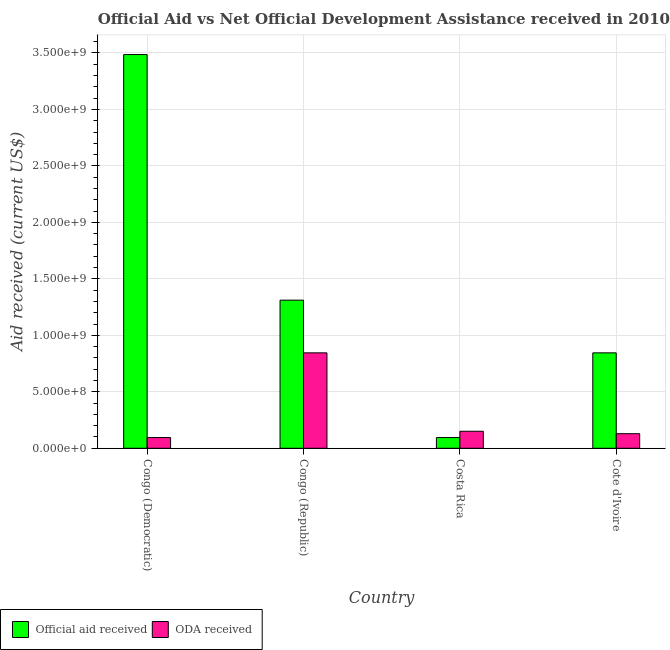How many different coloured bars are there?
Provide a short and direct response. 2. How many groups of bars are there?
Keep it short and to the point. 4. What is the label of the 2nd group of bars from the left?
Your answer should be compact. Congo (Republic). In how many cases, is the number of bars for a given country not equal to the number of legend labels?
Your response must be concise. 0. What is the official aid received in Costa Rica?
Ensure brevity in your answer.  9.50e+07. Across all countries, what is the maximum oda received?
Offer a very short reply. 8.45e+08. Across all countries, what is the minimum official aid received?
Offer a very short reply. 9.50e+07. In which country was the oda received maximum?
Provide a short and direct response. Congo (Republic). What is the total official aid received in the graph?
Give a very brief answer. 5.74e+09. What is the difference between the official aid received in Costa Rica and that in Cote d'Ivoire?
Ensure brevity in your answer.  -7.50e+08. What is the difference between the official aid received in Costa Rica and the oda received in Cote d'Ivoire?
Your response must be concise. -3.41e+07. What is the average oda received per country?
Give a very brief answer. 3.05e+08. What is the difference between the official aid received and oda received in Congo (Democratic)?
Provide a succinct answer. 3.39e+09. What is the ratio of the official aid received in Costa Rica to that in Cote d'Ivoire?
Make the answer very short. 0.11. Is the oda received in Costa Rica less than that in Cote d'Ivoire?
Give a very brief answer. No. What is the difference between the highest and the second highest oda received?
Your answer should be compact. 6.94e+08. What is the difference between the highest and the lowest official aid received?
Ensure brevity in your answer.  3.39e+09. What does the 1st bar from the left in Costa Rica represents?
Your answer should be compact. Official aid received. What does the 1st bar from the right in Cote d'Ivoire represents?
Give a very brief answer. ODA received. How many bars are there?
Your response must be concise. 8. Are all the bars in the graph horizontal?
Your response must be concise. No. How many countries are there in the graph?
Provide a short and direct response. 4. Are the values on the major ticks of Y-axis written in scientific E-notation?
Ensure brevity in your answer.  Yes. Does the graph contain grids?
Your response must be concise. Yes. Where does the legend appear in the graph?
Provide a succinct answer. Bottom left. How are the legend labels stacked?
Make the answer very short. Horizontal. What is the title of the graph?
Make the answer very short. Official Aid vs Net Official Development Assistance received in 2010 . What is the label or title of the Y-axis?
Offer a very short reply. Aid received (current US$). What is the Aid received (current US$) of Official aid received in Congo (Democratic)?
Ensure brevity in your answer.  3.49e+09. What is the Aid received (current US$) in ODA received in Congo (Democratic)?
Your answer should be very brief. 9.50e+07. What is the Aid received (current US$) of Official aid received in Congo (Republic)?
Provide a succinct answer. 1.31e+09. What is the Aid received (current US$) in ODA received in Congo (Republic)?
Ensure brevity in your answer.  8.45e+08. What is the Aid received (current US$) in Official aid received in Costa Rica?
Offer a terse response. 9.50e+07. What is the Aid received (current US$) of ODA received in Costa Rica?
Your answer should be very brief. 1.51e+08. What is the Aid received (current US$) of Official aid received in Cote d'Ivoire?
Provide a succinct answer. 8.45e+08. What is the Aid received (current US$) in ODA received in Cote d'Ivoire?
Your answer should be very brief. 1.29e+08. Across all countries, what is the maximum Aid received (current US$) in Official aid received?
Offer a very short reply. 3.49e+09. Across all countries, what is the maximum Aid received (current US$) of ODA received?
Your response must be concise. 8.45e+08. Across all countries, what is the minimum Aid received (current US$) of Official aid received?
Give a very brief answer. 9.50e+07. Across all countries, what is the minimum Aid received (current US$) in ODA received?
Your response must be concise. 9.50e+07. What is the total Aid received (current US$) in Official aid received in the graph?
Give a very brief answer. 5.74e+09. What is the total Aid received (current US$) in ODA received in the graph?
Keep it short and to the point. 1.22e+09. What is the difference between the Aid received (current US$) of Official aid received in Congo (Democratic) and that in Congo (Republic)?
Make the answer very short. 2.17e+09. What is the difference between the Aid received (current US$) of ODA received in Congo (Democratic) and that in Congo (Republic)?
Keep it short and to the point. -7.50e+08. What is the difference between the Aid received (current US$) in Official aid received in Congo (Democratic) and that in Costa Rica?
Make the answer very short. 3.39e+09. What is the difference between the Aid received (current US$) of ODA received in Congo (Democratic) and that in Costa Rica?
Offer a terse response. -5.57e+07. What is the difference between the Aid received (current US$) of Official aid received in Congo (Democratic) and that in Cote d'Ivoire?
Provide a short and direct response. 2.64e+09. What is the difference between the Aid received (current US$) in ODA received in Congo (Democratic) and that in Cote d'Ivoire?
Give a very brief answer. -3.41e+07. What is the difference between the Aid received (current US$) in Official aid received in Congo (Republic) and that in Costa Rica?
Your answer should be very brief. 1.22e+09. What is the difference between the Aid received (current US$) of ODA received in Congo (Republic) and that in Costa Rica?
Provide a succinct answer. 6.94e+08. What is the difference between the Aid received (current US$) of Official aid received in Congo (Republic) and that in Cote d'Ivoire?
Ensure brevity in your answer.  4.67e+08. What is the difference between the Aid received (current US$) in ODA received in Congo (Republic) and that in Cote d'Ivoire?
Your answer should be very brief. 7.16e+08. What is the difference between the Aid received (current US$) in Official aid received in Costa Rica and that in Cote d'Ivoire?
Your answer should be very brief. -7.50e+08. What is the difference between the Aid received (current US$) of ODA received in Costa Rica and that in Cote d'Ivoire?
Your response must be concise. 2.16e+07. What is the difference between the Aid received (current US$) of Official aid received in Congo (Democratic) and the Aid received (current US$) of ODA received in Congo (Republic)?
Ensure brevity in your answer.  2.64e+09. What is the difference between the Aid received (current US$) of Official aid received in Congo (Democratic) and the Aid received (current US$) of ODA received in Costa Rica?
Your answer should be very brief. 3.34e+09. What is the difference between the Aid received (current US$) in Official aid received in Congo (Democratic) and the Aid received (current US$) in ODA received in Cote d'Ivoire?
Provide a succinct answer. 3.36e+09. What is the difference between the Aid received (current US$) in Official aid received in Congo (Republic) and the Aid received (current US$) in ODA received in Costa Rica?
Ensure brevity in your answer.  1.16e+09. What is the difference between the Aid received (current US$) in Official aid received in Congo (Republic) and the Aid received (current US$) in ODA received in Cote d'Ivoire?
Your answer should be very brief. 1.18e+09. What is the difference between the Aid received (current US$) of Official aid received in Costa Rica and the Aid received (current US$) of ODA received in Cote d'Ivoire?
Your response must be concise. -3.41e+07. What is the average Aid received (current US$) of Official aid received per country?
Ensure brevity in your answer.  1.43e+09. What is the average Aid received (current US$) of ODA received per country?
Offer a very short reply. 3.05e+08. What is the difference between the Aid received (current US$) in Official aid received and Aid received (current US$) in ODA received in Congo (Democratic)?
Make the answer very short. 3.39e+09. What is the difference between the Aid received (current US$) in Official aid received and Aid received (current US$) in ODA received in Congo (Republic)?
Make the answer very short. 4.67e+08. What is the difference between the Aid received (current US$) of Official aid received and Aid received (current US$) of ODA received in Costa Rica?
Ensure brevity in your answer.  -5.57e+07. What is the difference between the Aid received (current US$) in Official aid received and Aid received (current US$) in ODA received in Cote d'Ivoire?
Provide a short and direct response. 7.16e+08. What is the ratio of the Aid received (current US$) of Official aid received in Congo (Democratic) to that in Congo (Republic)?
Your answer should be compact. 2.66. What is the ratio of the Aid received (current US$) of ODA received in Congo (Democratic) to that in Congo (Republic)?
Ensure brevity in your answer.  0.11. What is the ratio of the Aid received (current US$) of Official aid received in Congo (Democratic) to that in Costa Rica?
Offer a terse response. 36.68. What is the ratio of the Aid received (current US$) in ODA received in Congo (Democratic) to that in Costa Rica?
Give a very brief answer. 0.63. What is the ratio of the Aid received (current US$) of Official aid received in Congo (Democratic) to that in Cote d'Ivoire?
Give a very brief answer. 4.13. What is the ratio of the Aid received (current US$) of ODA received in Congo (Democratic) to that in Cote d'Ivoire?
Keep it short and to the point. 0.74. What is the ratio of the Aid received (current US$) in Official aid received in Congo (Republic) to that in Costa Rica?
Your response must be concise. 13.8. What is the ratio of the Aid received (current US$) of ODA received in Congo (Republic) to that in Costa Rica?
Make the answer very short. 5.61. What is the ratio of the Aid received (current US$) in Official aid received in Congo (Republic) to that in Cote d'Ivoire?
Your answer should be very brief. 1.55. What is the ratio of the Aid received (current US$) in ODA received in Congo (Republic) to that in Cote d'Ivoire?
Offer a very short reply. 6.54. What is the ratio of the Aid received (current US$) in Official aid received in Costa Rica to that in Cote d'Ivoire?
Make the answer very short. 0.11. What is the ratio of the Aid received (current US$) in ODA received in Costa Rica to that in Cote d'Ivoire?
Your answer should be compact. 1.17. What is the difference between the highest and the second highest Aid received (current US$) in Official aid received?
Offer a terse response. 2.17e+09. What is the difference between the highest and the second highest Aid received (current US$) of ODA received?
Keep it short and to the point. 6.94e+08. What is the difference between the highest and the lowest Aid received (current US$) of Official aid received?
Offer a very short reply. 3.39e+09. What is the difference between the highest and the lowest Aid received (current US$) in ODA received?
Your response must be concise. 7.50e+08. 